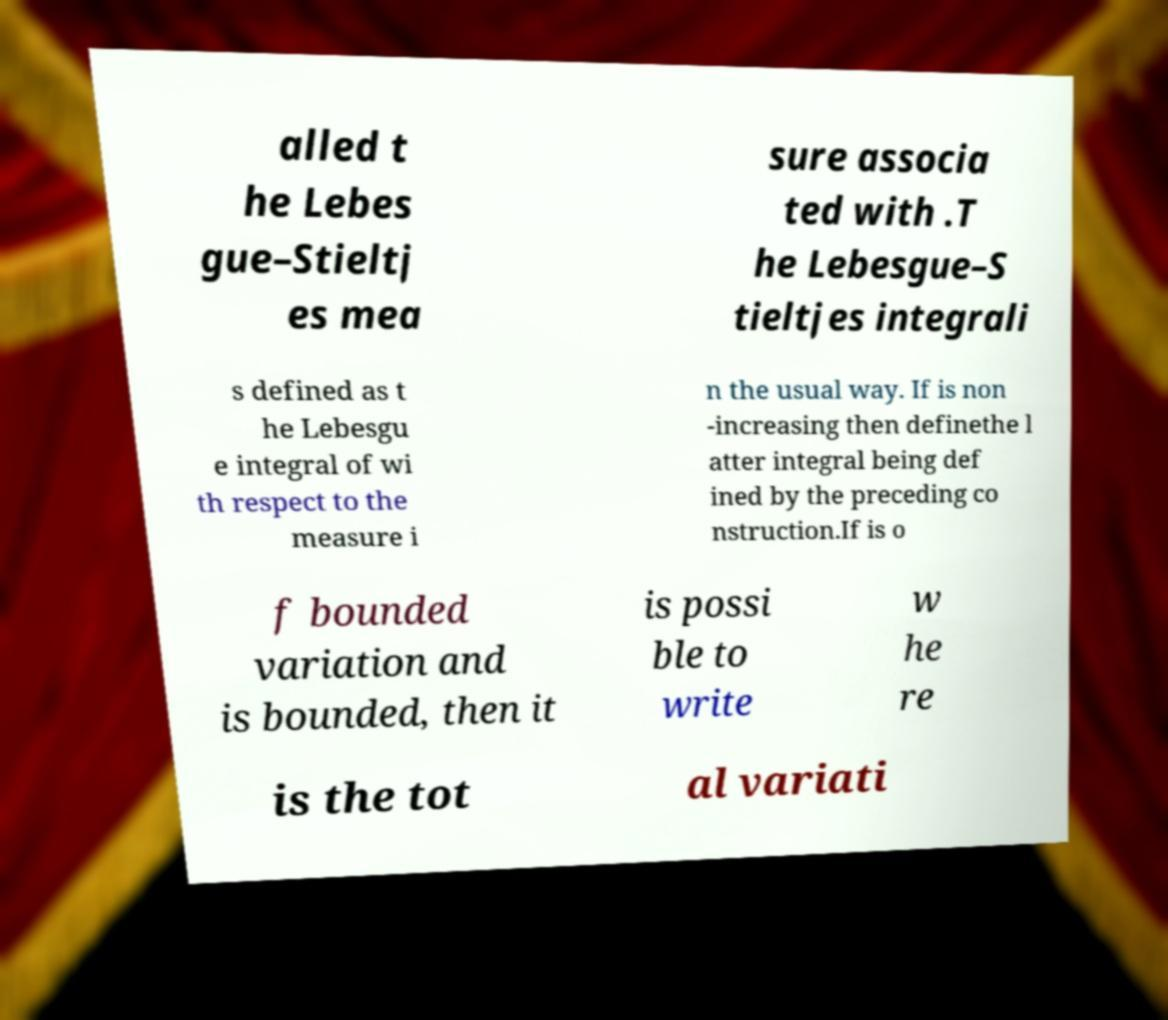Can you accurately transcribe the text from the provided image for me? alled t he Lebes gue–Stieltj es mea sure associa ted with .T he Lebesgue–S tieltjes integrali s defined as t he Lebesgu e integral of wi th respect to the measure i n the usual way. If is non -increasing then definethe l atter integral being def ined by the preceding co nstruction.If is o f bounded variation and is bounded, then it is possi ble to write w he re is the tot al variati 